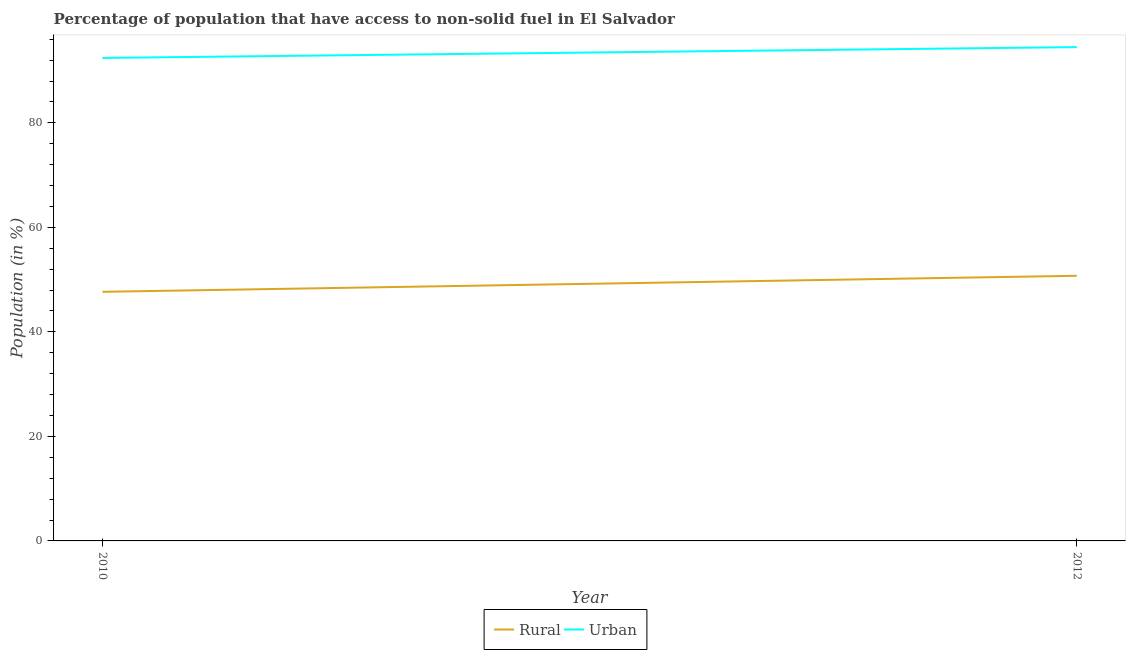Is the number of lines equal to the number of legend labels?
Your response must be concise. Yes. What is the rural population in 2012?
Provide a short and direct response. 50.73. Across all years, what is the maximum rural population?
Your response must be concise. 50.73. Across all years, what is the minimum urban population?
Your answer should be compact. 92.41. In which year was the urban population minimum?
Provide a succinct answer. 2010. What is the total urban population in the graph?
Provide a short and direct response. 186.9. What is the difference between the urban population in 2010 and that in 2012?
Offer a very short reply. -2.07. What is the difference between the urban population in 2012 and the rural population in 2010?
Make the answer very short. 46.82. What is the average urban population per year?
Your answer should be compact. 93.45. In the year 2012, what is the difference between the urban population and rural population?
Your answer should be very brief. 43.76. What is the ratio of the rural population in 2010 to that in 2012?
Your response must be concise. 0.94. Is the urban population strictly greater than the rural population over the years?
Your answer should be compact. Yes. Is the urban population strictly less than the rural population over the years?
Your answer should be compact. No. How many lines are there?
Provide a succinct answer. 2. How many years are there in the graph?
Offer a very short reply. 2. Where does the legend appear in the graph?
Your response must be concise. Bottom center. How many legend labels are there?
Your response must be concise. 2. How are the legend labels stacked?
Keep it short and to the point. Horizontal. What is the title of the graph?
Keep it short and to the point. Percentage of population that have access to non-solid fuel in El Salvador. Does "Stunting" appear as one of the legend labels in the graph?
Your answer should be compact. No. What is the Population (in %) of Rural in 2010?
Ensure brevity in your answer.  47.66. What is the Population (in %) of Urban in 2010?
Provide a short and direct response. 92.41. What is the Population (in %) of Rural in 2012?
Provide a short and direct response. 50.73. What is the Population (in %) of Urban in 2012?
Offer a very short reply. 94.49. Across all years, what is the maximum Population (in %) of Rural?
Provide a short and direct response. 50.73. Across all years, what is the maximum Population (in %) in Urban?
Your answer should be very brief. 94.49. Across all years, what is the minimum Population (in %) in Rural?
Your answer should be very brief. 47.66. Across all years, what is the minimum Population (in %) of Urban?
Your answer should be compact. 92.41. What is the total Population (in %) of Rural in the graph?
Make the answer very short. 98.39. What is the total Population (in %) in Urban in the graph?
Provide a short and direct response. 186.9. What is the difference between the Population (in %) of Rural in 2010 and that in 2012?
Your response must be concise. -3.07. What is the difference between the Population (in %) of Urban in 2010 and that in 2012?
Offer a very short reply. -2.07. What is the difference between the Population (in %) of Rural in 2010 and the Population (in %) of Urban in 2012?
Offer a terse response. -46.82. What is the average Population (in %) in Rural per year?
Your answer should be very brief. 49.2. What is the average Population (in %) in Urban per year?
Give a very brief answer. 93.45. In the year 2010, what is the difference between the Population (in %) in Rural and Population (in %) in Urban?
Provide a succinct answer. -44.75. In the year 2012, what is the difference between the Population (in %) in Rural and Population (in %) in Urban?
Provide a succinct answer. -43.76. What is the ratio of the Population (in %) in Rural in 2010 to that in 2012?
Keep it short and to the point. 0.94. What is the ratio of the Population (in %) of Urban in 2010 to that in 2012?
Offer a very short reply. 0.98. What is the difference between the highest and the second highest Population (in %) of Rural?
Give a very brief answer. 3.07. What is the difference between the highest and the second highest Population (in %) in Urban?
Your answer should be compact. 2.07. What is the difference between the highest and the lowest Population (in %) of Rural?
Your answer should be compact. 3.07. What is the difference between the highest and the lowest Population (in %) in Urban?
Keep it short and to the point. 2.07. 